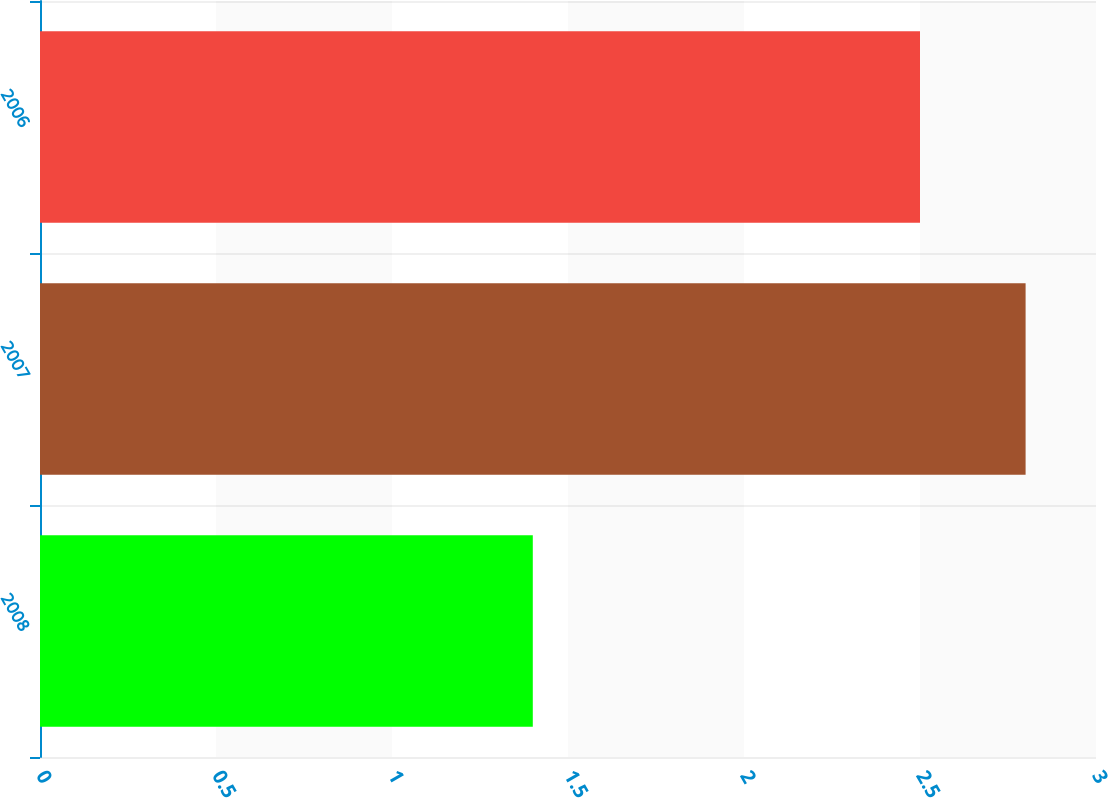Convert chart. <chart><loc_0><loc_0><loc_500><loc_500><bar_chart><fcel>2008<fcel>2007<fcel>2006<nl><fcel>1.4<fcel>2.8<fcel>2.5<nl></chart> 